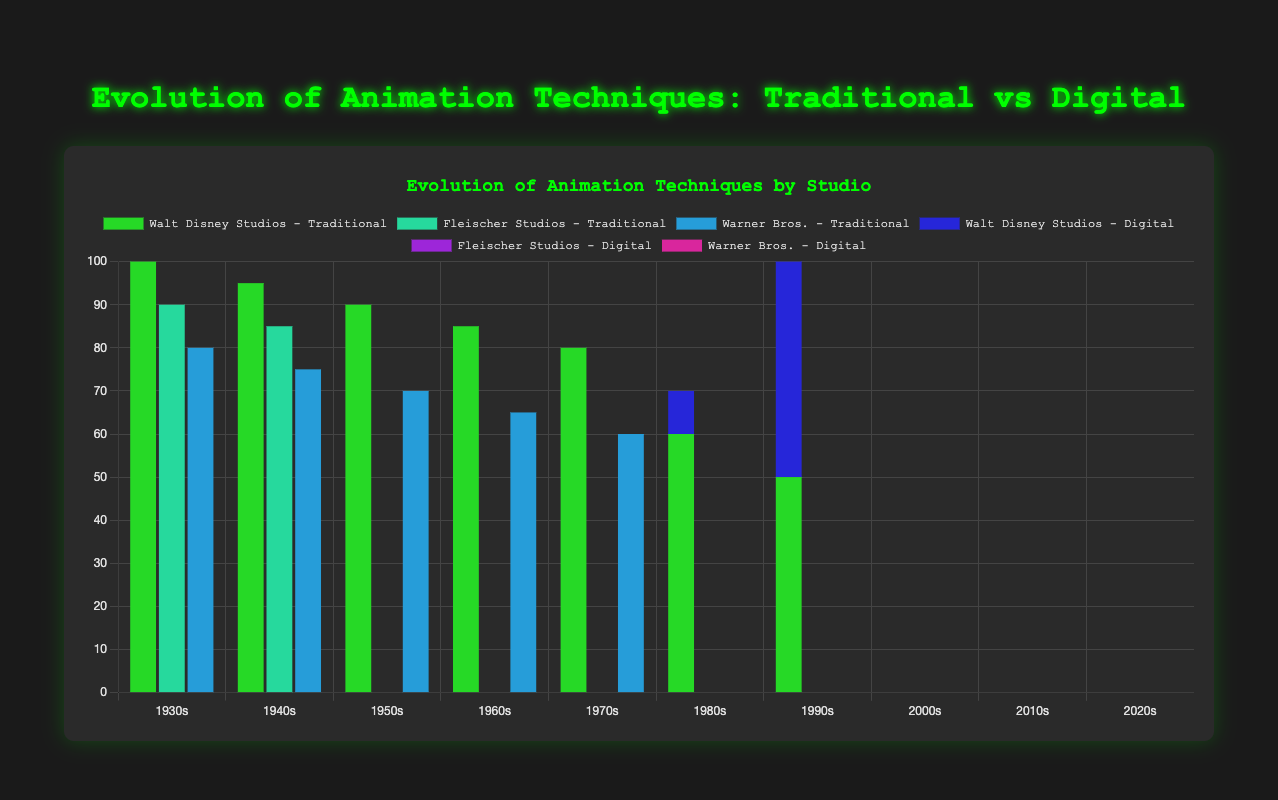Which studio had the highest use of traditional animation in the 1930s? By looking at the 1930s segment, Walt Disney Studios shows the highest value for traditional animation
Answer: Walt Disney Studios When did Pixar Animation Studios first appear in the chart, and what was their ratio of traditional to digital animation methods at that time? Pixar Animation Studios first appears in the 1990s section with values of 10 for traditional and 90 for digital methods, making the ratio 10:90
Answer: 1990s, 10:90 How did Warner Bros.' usage of traditional animation change from the 1930s to the 1960s? Comparing the bars for Warner Bros. from the 1930s (80) to the 1960s (65), it shows a decrease of 15 units
Answer: Decreased by 15 units Which studio shifted to predominantly digital methods the earliest and in which decade? Pixar Animation Studios shifted to predominantly digital methods in the 1990s, with a significant digital output shown by the higher bar for digital at that time
Answer: Pixar Animation Studios, 1990s How does the proportion of digital to traditional animation for DreamWorks Animation in the 2010s compare to that in the 2000s? In the 2000s, DreamWorks Animation had a 95% digital and in the 2010s, it increased to 98% digital, indicating an increase in the proportion of digital animation
Answer: Increased from 95 to 98 What is the overall trend in digital animation from the 1930s to the 2020s? Observing the height of the digital bars increasing over time, it shows that digital animation techniques generally increase as we move from the 1930s to the 2020s
Answer: General increase Which studio had the largest discrepancy between traditional and digital methods in the 1990s? Pixar Animation Studios in the 1990s had the largest discrepancy, with values of 10 for traditional and 90 for digital, making an 80-point difference
Answer: Pixar Animation Studios Compare the use of digital animation by Walt Disney Studios in the 2000s and 2010s. Walt Disney Studios does not appear in the 2000s and 2010s sections in the provided data, indicating they did not have significant digital animation production reported
Answer: No significant production reported Calculate the combined use of digital animation for all studios in the 2020s. Adding up the digital values for Pixar Animation Studios (98), DreamWorks Animation (99), Sony Pictures Animation (97) gives 294
Answer: 294 How many studios used purely traditional animation in the 1960s? Looking at the 1960s, all studios (Walt Disney Studios, Hanna-Barbera, Warner Bros.) show 0 digital values, indicating purely traditional animation
Answer: 3 studios 